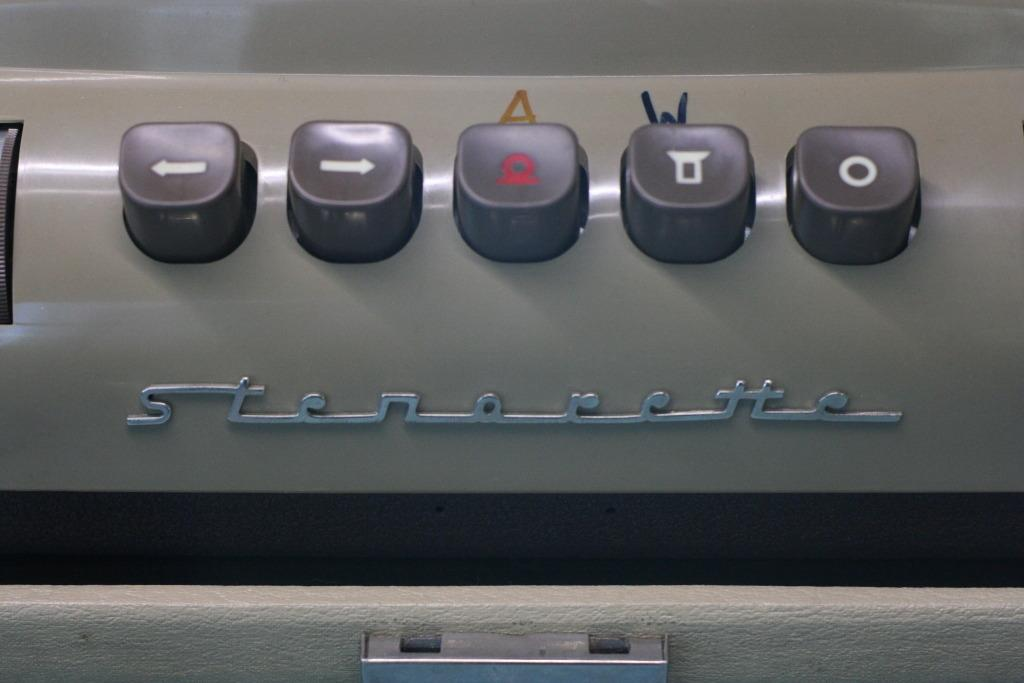<image>
Provide a brief description of the given image. Five black buttons with symbols on them above cursive Sterorette letters 